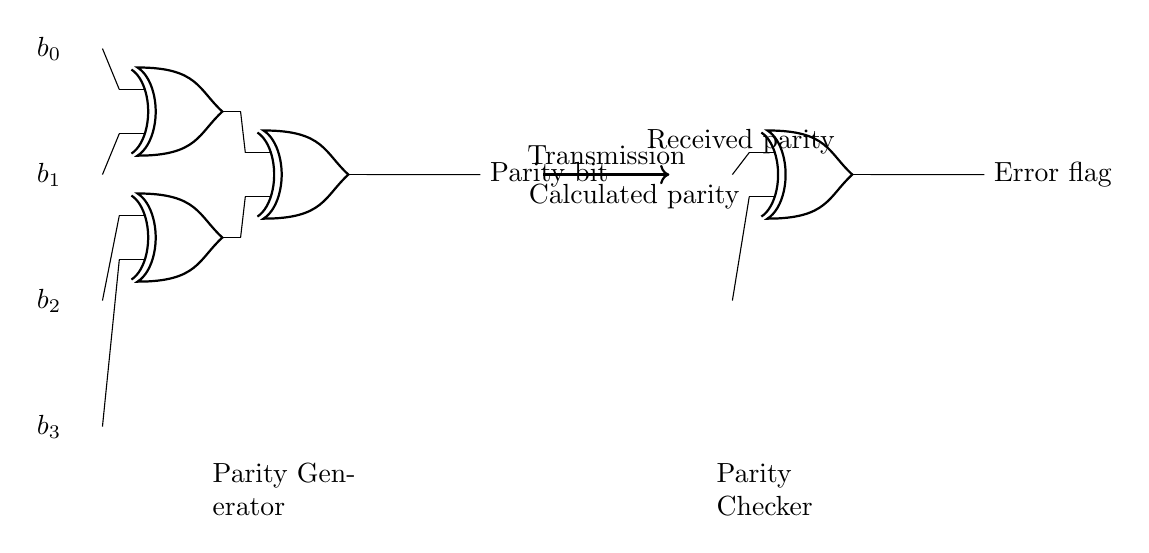What is the input bit labeled as the highest bit? The highest input bit is labeled as b0, which is positioned at the top of the input section in the circuit diagram.
Answer: b0 How many XOR gates are used in the circuit? There are four XOR gates in total: three in the parity generator section and one in the parity checker section.
Answer: Four What signal does the output of the parity generator represent? The output of the parity generator represents the parity bit, indicating whether the number of ones in the data is odd or even.
Answer: Parity bit What is the purpose of the XOR gate in the parity checker? The XOR gate in the parity checker is used to compare the received parity with the calculated parity to determine if an error has occurred during transmission.
Answer: Error detection If four bits are inputted, how many outputs does the circuit generate? The circuit generates two outputs: the parity bit from the generator and the error flag from the checker.
Answer: Two What happens if the output of the parity checker is high? If the output of the parity checker is high, it indicates a discrepancy between the received and calculated parity, signaling the presence of an error in the transmitted data.
Answer: Error flag 